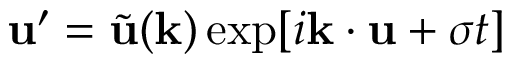<formula> <loc_0><loc_0><loc_500><loc_500>u ^ { \prime } = \tilde { u } ( k ) \exp [ i k \cdot u + \sigma t ]</formula> 